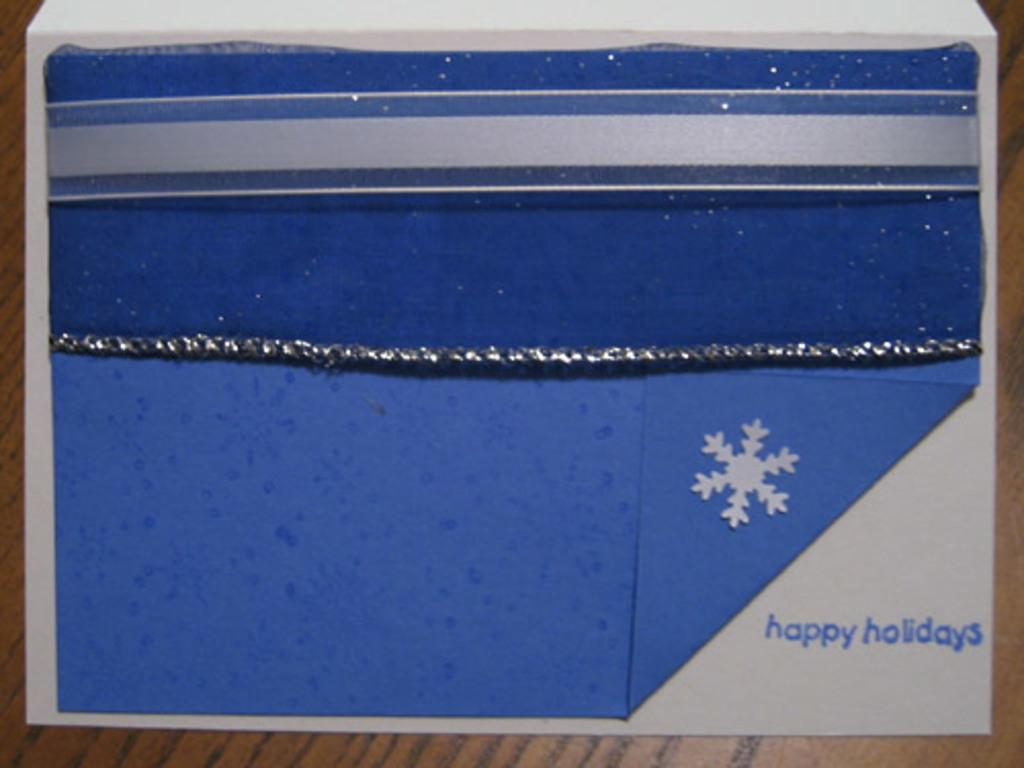Provide a one-sentence caption for the provided image. Something blue that has a snow flake and the words "Happy holidays" on it. 